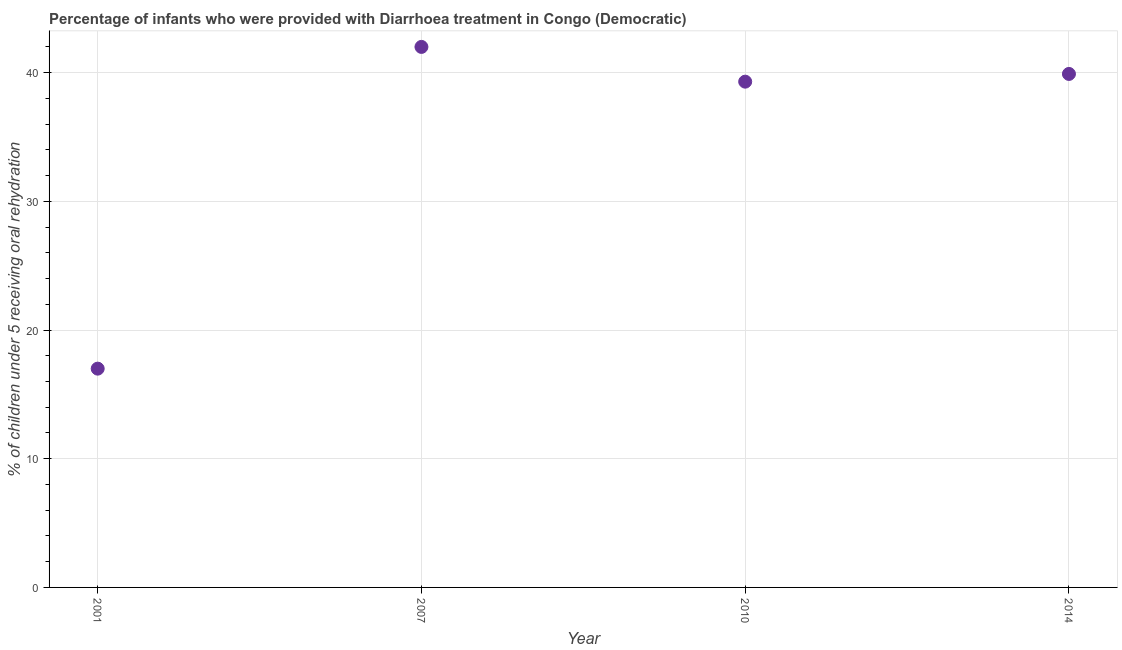Across all years, what is the minimum percentage of children who were provided with treatment diarrhoea?
Ensure brevity in your answer.  17. In which year was the percentage of children who were provided with treatment diarrhoea minimum?
Provide a short and direct response. 2001. What is the sum of the percentage of children who were provided with treatment diarrhoea?
Keep it short and to the point. 138.2. What is the average percentage of children who were provided with treatment diarrhoea per year?
Give a very brief answer. 34.55. What is the median percentage of children who were provided with treatment diarrhoea?
Ensure brevity in your answer.  39.6. Do a majority of the years between 2007 and 2010 (inclusive) have percentage of children who were provided with treatment diarrhoea greater than 20 %?
Give a very brief answer. Yes. What is the ratio of the percentage of children who were provided with treatment diarrhoea in 2007 to that in 2014?
Your answer should be compact. 1.05. Is the percentage of children who were provided with treatment diarrhoea in 2007 less than that in 2014?
Give a very brief answer. No. Is the difference between the percentage of children who were provided with treatment diarrhoea in 2007 and 2010 greater than the difference between any two years?
Provide a succinct answer. No. What is the difference between the highest and the second highest percentage of children who were provided with treatment diarrhoea?
Your answer should be very brief. 2.1. What is the difference between the highest and the lowest percentage of children who were provided with treatment diarrhoea?
Provide a short and direct response. 25. In how many years, is the percentage of children who were provided with treatment diarrhoea greater than the average percentage of children who were provided with treatment diarrhoea taken over all years?
Provide a short and direct response. 3. How many dotlines are there?
Your answer should be very brief. 1. What is the difference between two consecutive major ticks on the Y-axis?
Ensure brevity in your answer.  10. Does the graph contain any zero values?
Ensure brevity in your answer.  No. What is the title of the graph?
Offer a terse response. Percentage of infants who were provided with Diarrhoea treatment in Congo (Democratic). What is the label or title of the X-axis?
Your answer should be very brief. Year. What is the label or title of the Y-axis?
Make the answer very short. % of children under 5 receiving oral rehydration. What is the % of children under 5 receiving oral rehydration in 2007?
Offer a very short reply. 42. What is the % of children under 5 receiving oral rehydration in 2010?
Your answer should be very brief. 39.3. What is the % of children under 5 receiving oral rehydration in 2014?
Make the answer very short. 39.9. What is the difference between the % of children under 5 receiving oral rehydration in 2001 and 2010?
Ensure brevity in your answer.  -22.3. What is the difference between the % of children under 5 receiving oral rehydration in 2001 and 2014?
Your answer should be compact. -22.9. What is the difference between the % of children under 5 receiving oral rehydration in 2007 and 2010?
Keep it short and to the point. 2.7. What is the ratio of the % of children under 5 receiving oral rehydration in 2001 to that in 2007?
Your answer should be very brief. 0.41. What is the ratio of the % of children under 5 receiving oral rehydration in 2001 to that in 2010?
Provide a short and direct response. 0.43. What is the ratio of the % of children under 5 receiving oral rehydration in 2001 to that in 2014?
Offer a terse response. 0.43. What is the ratio of the % of children under 5 receiving oral rehydration in 2007 to that in 2010?
Your response must be concise. 1.07. What is the ratio of the % of children under 5 receiving oral rehydration in 2007 to that in 2014?
Your response must be concise. 1.05. What is the ratio of the % of children under 5 receiving oral rehydration in 2010 to that in 2014?
Offer a terse response. 0.98. 